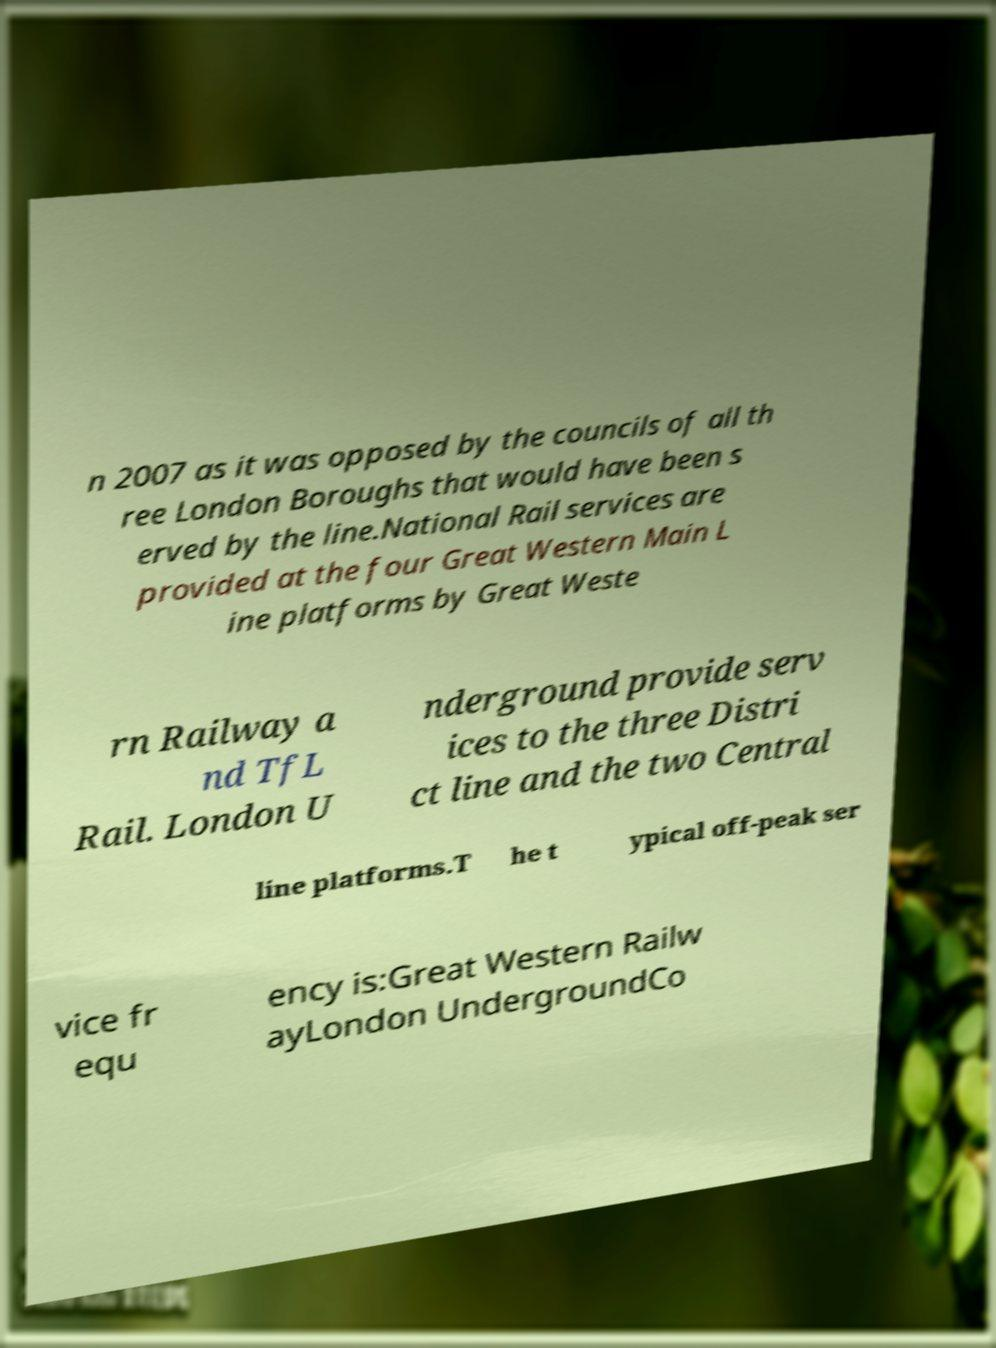What messages or text are displayed in this image? I need them in a readable, typed format. n 2007 as it was opposed by the councils of all th ree London Boroughs that would have been s erved by the line.National Rail services are provided at the four Great Western Main L ine platforms by Great Weste rn Railway a nd TfL Rail. London U nderground provide serv ices to the three Distri ct line and the two Central line platforms.T he t ypical off-peak ser vice fr equ ency is:Great Western Railw ayLondon UndergroundCo 